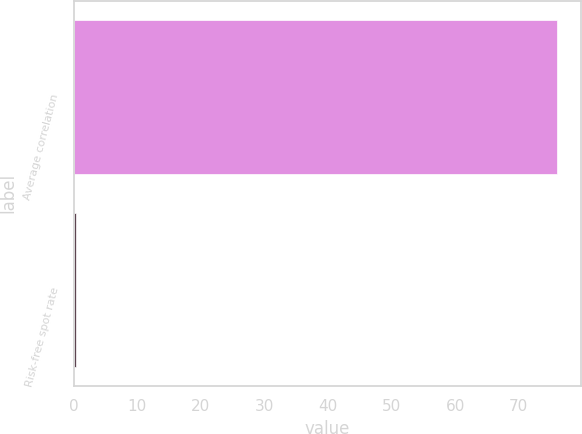<chart> <loc_0><loc_0><loc_500><loc_500><bar_chart><fcel>Average correlation<fcel>Risk-free spot rate<nl><fcel>76<fcel>0.4<nl></chart> 